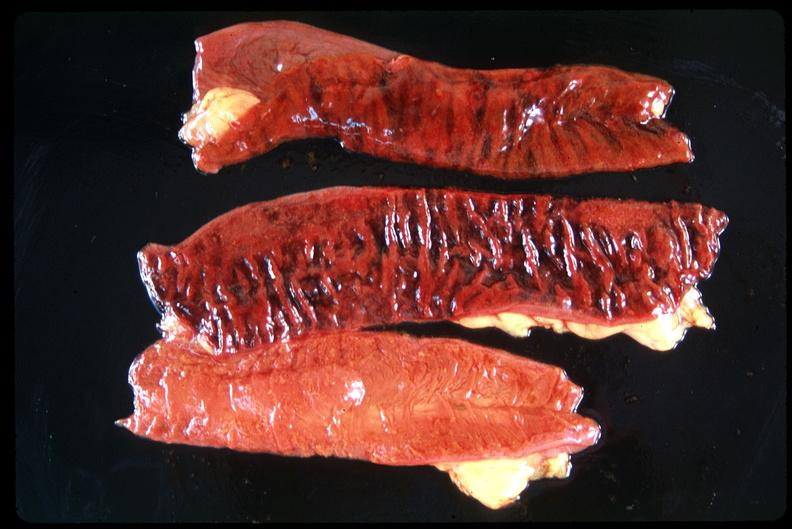where does this belong to?
Answer the question using a single word or phrase. Gastrointestinal system 